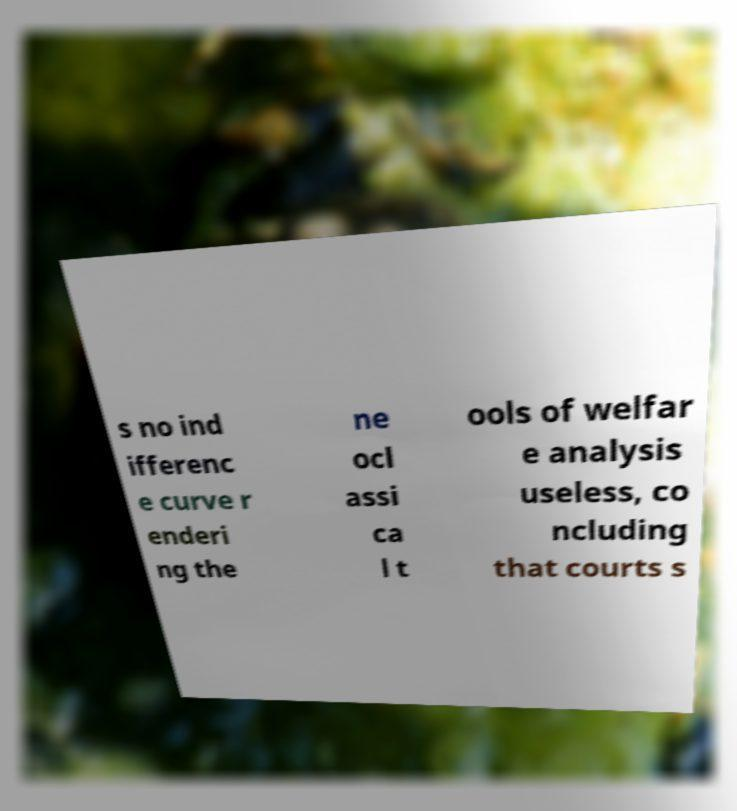For documentation purposes, I need the text within this image transcribed. Could you provide that? s no ind ifferenc e curve r enderi ng the ne ocl assi ca l t ools of welfar e analysis useless, co ncluding that courts s 